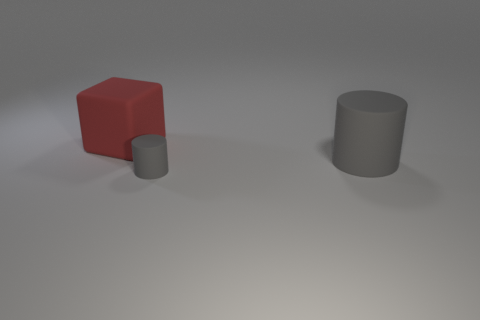Add 2 large cubes. How many objects exist? 5 Subtract all cylinders. How many objects are left? 1 Subtract 0 purple cylinders. How many objects are left? 3 Subtract all red cubes. Subtract all tiny gray rubber cylinders. How many objects are left? 1 Add 1 tiny gray rubber things. How many tiny gray rubber things are left? 2 Add 2 cylinders. How many cylinders exist? 4 